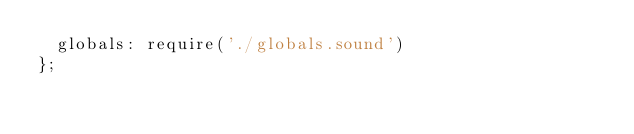<code> <loc_0><loc_0><loc_500><loc_500><_JavaScript_>  globals: require('./globals.sound')
};
</code> 